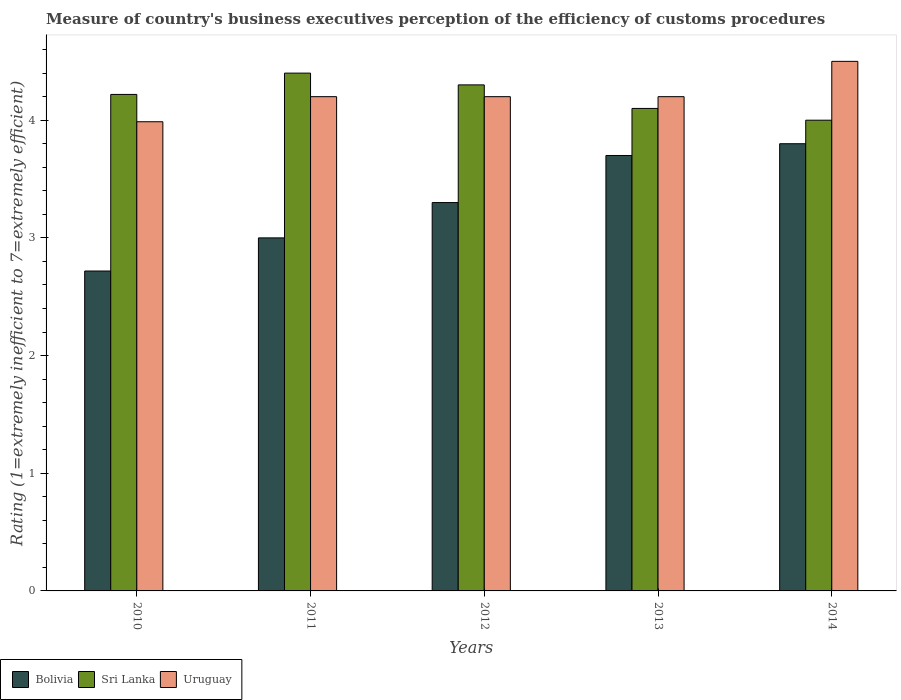How many groups of bars are there?
Make the answer very short. 5. Are the number of bars per tick equal to the number of legend labels?
Provide a short and direct response. Yes. Are the number of bars on each tick of the X-axis equal?
Make the answer very short. Yes. What is the rating of the efficiency of customs procedure in Sri Lanka in 2014?
Ensure brevity in your answer.  4. What is the total rating of the efficiency of customs procedure in Uruguay in the graph?
Your answer should be very brief. 21.09. What is the difference between the rating of the efficiency of customs procedure in Bolivia in 2010 and that in 2014?
Your response must be concise. -1.08. What is the difference between the rating of the efficiency of customs procedure in Sri Lanka in 2010 and the rating of the efficiency of customs procedure in Uruguay in 2013?
Offer a terse response. 0.02. What is the average rating of the efficiency of customs procedure in Uruguay per year?
Your answer should be compact. 4.22. In the year 2012, what is the difference between the rating of the efficiency of customs procedure in Bolivia and rating of the efficiency of customs procedure in Sri Lanka?
Provide a short and direct response. -1. What is the ratio of the rating of the efficiency of customs procedure in Uruguay in 2010 to that in 2012?
Offer a terse response. 0.95. Is the rating of the efficiency of customs procedure in Uruguay in 2011 less than that in 2013?
Ensure brevity in your answer.  No. Is the difference between the rating of the efficiency of customs procedure in Bolivia in 2011 and 2014 greater than the difference between the rating of the efficiency of customs procedure in Sri Lanka in 2011 and 2014?
Provide a short and direct response. No. What is the difference between the highest and the second highest rating of the efficiency of customs procedure in Sri Lanka?
Offer a very short reply. 0.1. What is the difference between the highest and the lowest rating of the efficiency of customs procedure in Sri Lanka?
Ensure brevity in your answer.  0.4. Is the sum of the rating of the efficiency of customs procedure in Uruguay in 2011 and 2013 greater than the maximum rating of the efficiency of customs procedure in Bolivia across all years?
Make the answer very short. Yes. What does the 2nd bar from the left in 2011 represents?
Ensure brevity in your answer.  Sri Lanka. What does the 3rd bar from the right in 2014 represents?
Provide a short and direct response. Bolivia. How many bars are there?
Provide a short and direct response. 15. What is the difference between two consecutive major ticks on the Y-axis?
Your answer should be very brief. 1. Does the graph contain any zero values?
Offer a terse response. No. How are the legend labels stacked?
Your answer should be very brief. Horizontal. What is the title of the graph?
Your answer should be very brief. Measure of country's business executives perception of the efficiency of customs procedures. Does "Austria" appear as one of the legend labels in the graph?
Offer a terse response. No. What is the label or title of the Y-axis?
Offer a terse response. Rating (1=extremely inefficient to 7=extremely efficient). What is the Rating (1=extremely inefficient to 7=extremely efficient) of Bolivia in 2010?
Ensure brevity in your answer.  2.72. What is the Rating (1=extremely inefficient to 7=extremely efficient) in Sri Lanka in 2010?
Your answer should be very brief. 4.22. What is the Rating (1=extremely inefficient to 7=extremely efficient) of Uruguay in 2010?
Keep it short and to the point. 3.99. What is the Rating (1=extremely inefficient to 7=extremely efficient) of Bolivia in 2011?
Give a very brief answer. 3. What is the Rating (1=extremely inefficient to 7=extremely efficient) of Sri Lanka in 2012?
Offer a very short reply. 4.3. What is the Rating (1=extremely inefficient to 7=extremely efficient) of Uruguay in 2012?
Your answer should be very brief. 4.2. What is the Rating (1=extremely inefficient to 7=extremely efficient) in Bolivia in 2014?
Ensure brevity in your answer.  3.8. What is the Rating (1=extremely inefficient to 7=extremely efficient) of Uruguay in 2014?
Your answer should be very brief. 4.5. Across all years, what is the maximum Rating (1=extremely inefficient to 7=extremely efficient) in Bolivia?
Your response must be concise. 3.8. Across all years, what is the minimum Rating (1=extremely inefficient to 7=extremely efficient) in Bolivia?
Offer a terse response. 2.72. Across all years, what is the minimum Rating (1=extremely inefficient to 7=extremely efficient) of Uruguay?
Give a very brief answer. 3.99. What is the total Rating (1=extremely inefficient to 7=extremely efficient) of Bolivia in the graph?
Your answer should be compact. 16.52. What is the total Rating (1=extremely inefficient to 7=extremely efficient) in Sri Lanka in the graph?
Offer a very short reply. 21.02. What is the total Rating (1=extremely inefficient to 7=extremely efficient) in Uruguay in the graph?
Keep it short and to the point. 21.09. What is the difference between the Rating (1=extremely inefficient to 7=extremely efficient) in Bolivia in 2010 and that in 2011?
Provide a short and direct response. -0.28. What is the difference between the Rating (1=extremely inefficient to 7=extremely efficient) of Sri Lanka in 2010 and that in 2011?
Keep it short and to the point. -0.18. What is the difference between the Rating (1=extremely inefficient to 7=extremely efficient) in Uruguay in 2010 and that in 2011?
Keep it short and to the point. -0.21. What is the difference between the Rating (1=extremely inefficient to 7=extremely efficient) of Bolivia in 2010 and that in 2012?
Make the answer very short. -0.58. What is the difference between the Rating (1=extremely inefficient to 7=extremely efficient) in Sri Lanka in 2010 and that in 2012?
Offer a terse response. -0.08. What is the difference between the Rating (1=extremely inefficient to 7=extremely efficient) in Uruguay in 2010 and that in 2012?
Provide a succinct answer. -0.21. What is the difference between the Rating (1=extremely inefficient to 7=extremely efficient) in Bolivia in 2010 and that in 2013?
Provide a short and direct response. -0.98. What is the difference between the Rating (1=extremely inefficient to 7=extremely efficient) in Sri Lanka in 2010 and that in 2013?
Provide a succinct answer. 0.12. What is the difference between the Rating (1=extremely inefficient to 7=extremely efficient) of Uruguay in 2010 and that in 2013?
Your response must be concise. -0.21. What is the difference between the Rating (1=extremely inefficient to 7=extremely efficient) in Bolivia in 2010 and that in 2014?
Your answer should be compact. -1.08. What is the difference between the Rating (1=extremely inefficient to 7=extremely efficient) in Sri Lanka in 2010 and that in 2014?
Keep it short and to the point. 0.22. What is the difference between the Rating (1=extremely inefficient to 7=extremely efficient) of Uruguay in 2010 and that in 2014?
Your response must be concise. -0.51. What is the difference between the Rating (1=extremely inefficient to 7=extremely efficient) of Sri Lanka in 2011 and that in 2012?
Ensure brevity in your answer.  0.1. What is the difference between the Rating (1=extremely inefficient to 7=extremely efficient) of Bolivia in 2011 and that in 2014?
Make the answer very short. -0.8. What is the difference between the Rating (1=extremely inefficient to 7=extremely efficient) in Sri Lanka in 2011 and that in 2014?
Your answer should be very brief. 0.4. What is the difference between the Rating (1=extremely inefficient to 7=extremely efficient) of Uruguay in 2011 and that in 2014?
Your response must be concise. -0.3. What is the difference between the Rating (1=extremely inefficient to 7=extremely efficient) in Uruguay in 2012 and that in 2013?
Your response must be concise. 0. What is the difference between the Rating (1=extremely inefficient to 7=extremely efficient) of Bolivia in 2012 and that in 2014?
Give a very brief answer. -0.5. What is the difference between the Rating (1=extremely inefficient to 7=extremely efficient) in Uruguay in 2013 and that in 2014?
Give a very brief answer. -0.3. What is the difference between the Rating (1=extremely inefficient to 7=extremely efficient) in Bolivia in 2010 and the Rating (1=extremely inefficient to 7=extremely efficient) in Sri Lanka in 2011?
Your response must be concise. -1.68. What is the difference between the Rating (1=extremely inefficient to 7=extremely efficient) in Bolivia in 2010 and the Rating (1=extremely inefficient to 7=extremely efficient) in Uruguay in 2011?
Provide a short and direct response. -1.48. What is the difference between the Rating (1=extremely inefficient to 7=extremely efficient) of Sri Lanka in 2010 and the Rating (1=extremely inefficient to 7=extremely efficient) of Uruguay in 2011?
Provide a short and direct response. 0.02. What is the difference between the Rating (1=extremely inefficient to 7=extremely efficient) of Bolivia in 2010 and the Rating (1=extremely inefficient to 7=extremely efficient) of Sri Lanka in 2012?
Ensure brevity in your answer.  -1.58. What is the difference between the Rating (1=extremely inefficient to 7=extremely efficient) of Bolivia in 2010 and the Rating (1=extremely inefficient to 7=extremely efficient) of Uruguay in 2012?
Your response must be concise. -1.48. What is the difference between the Rating (1=extremely inefficient to 7=extremely efficient) in Sri Lanka in 2010 and the Rating (1=extremely inefficient to 7=extremely efficient) in Uruguay in 2012?
Your answer should be very brief. 0.02. What is the difference between the Rating (1=extremely inefficient to 7=extremely efficient) of Bolivia in 2010 and the Rating (1=extremely inefficient to 7=extremely efficient) of Sri Lanka in 2013?
Give a very brief answer. -1.38. What is the difference between the Rating (1=extremely inefficient to 7=extremely efficient) of Bolivia in 2010 and the Rating (1=extremely inefficient to 7=extremely efficient) of Uruguay in 2013?
Make the answer very short. -1.48. What is the difference between the Rating (1=extremely inefficient to 7=extremely efficient) of Sri Lanka in 2010 and the Rating (1=extremely inefficient to 7=extremely efficient) of Uruguay in 2013?
Give a very brief answer. 0.02. What is the difference between the Rating (1=extremely inefficient to 7=extremely efficient) in Bolivia in 2010 and the Rating (1=extremely inefficient to 7=extremely efficient) in Sri Lanka in 2014?
Your answer should be compact. -1.28. What is the difference between the Rating (1=extremely inefficient to 7=extremely efficient) of Bolivia in 2010 and the Rating (1=extremely inefficient to 7=extremely efficient) of Uruguay in 2014?
Provide a succinct answer. -1.78. What is the difference between the Rating (1=extremely inefficient to 7=extremely efficient) of Sri Lanka in 2010 and the Rating (1=extremely inefficient to 7=extremely efficient) of Uruguay in 2014?
Offer a terse response. -0.28. What is the difference between the Rating (1=extremely inefficient to 7=extremely efficient) of Bolivia in 2011 and the Rating (1=extremely inefficient to 7=extremely efficient) of Sri Lanka in 2012?
Provide a succinct answer. -1.3. What is the difference between the Rating (1=extremely inefficient to 7=extremely efficient) in Bolivia in 2011 and the Rating (1=extremely inefficient to 7=extremely efficient) in Uruguay in 2013?
Your answer should be compact. -1.2. What is the difference between the Rating (1=extremely inefficient to 7=extremely efficient) in Sri Lanka in 2011 and the Rating (1=extremely inefficient to 7=extremely efficient) in Uruguay in 2013?
Your response must be concise. 0.2. What is the difference between the Rating (1=extremely inefficient to 7=extremely efficient) of Bolivia in 2011 and the Rating (1=extremely inefficient to 7=extremely efficient) of Sri Lanka in 2014?
Provide a short and direct response. -1. What is the difference between the Rating (1=extremely inefficient to 7=extremely efficient) in Bolivia in 2012 and the Rating (1=extremely inefficient to 7=extremely efficient) in Uruguay in 2013?
Provide a succinct answer. -0.9. What is the difference between the Rating (1=extremely inefficient to 7=extremely efficient) in Bolivia in 2012 and the Rating (1=extremely inefficient to 7=extremely efficient) in Sri Lanka in 2014?
Your answer should be very brief. -0.7. What is the difference between the Rating (1=extremely inefficient to 7=extremely efficient) of Sri Lanka in 2013 and the Rating (1=extremely inefficient to 7=extremely efficient) of Uruguay in 2014?
Your answer should be very brief. -0.4. What is the average Rating (1=extremely inefficient to 7=extremely efficient) in Bolivia per year?
Your answer should be compact. 3.3. What is the average Rating (1=extremely inefficient to 7=extremely efficient) in Sri Lanka per year?
Your response must be concise. 4.2. What is the average Rating (1=extremely inefficient to 7=extremely efficient) of Uruguay per year?
Your answer should be very brief. 4.22. In the year 2010, what is the difference between the Rating (1=extremely inefficient to 7=extremely efficient) of Bolivia and Rating (1=extremely inefficient to 7=extremely efficient) of Sri Lanka?
Your answer should be compact. -1.5. In the year 2010, what is the difference between the Rating (1=extremely inefficient to 7=extremely efficient) in Bolivia and Rating (1=extremely inefficient to 7=extremely efficient) in Uruguay?
Make the answer very short. -1.27. In the year 2010, what is the difference between the Rating (1=extremely inefficient to 7=extremely efficient) in Sri Lanka and Rating (1=extremely inefficient to 7=extremely efficient) in Uruguay?
Provide a short and direct response. 0.23. In the year 2011, what is the difference between the Rating (1=extremely inefficient to 7=extremely efficient) in Bolivia and Rating (1=extremely inefficient to 7=extremely efficient) in Sri Lanka?
Keep it short and to the point. -1.4. In the year 2011, what is the difference between the Rating (1=extremely inefficient to 7=extremely efficient) of Sri Lanka and Rating (1=extremely inefficient to 7=extremely efficient) of Uruguay?
Ensure brevity in your answer.  0.2. In the year 2012, what is the difference between the Rating (1=extremely inefficient to 7=extremely efficient) in Bolivia and Rating (1=extremely inefficient to 7=extremely efficient) in Uruguay?
Offer a very short reply. -0.9. In the year 2013, what is the difference between the Rating (1=extremely inefficient to 7=extremely efficient) in Bolivia and Rating (1=extremely inefficient to 7=extremely efficient) in Uruguay?
Give a very brief answer. -0.5. What is the ratio of the Rating (1=extremely inefficient to 7=extremely efficient) of Bolivia in 2010 to that in 2011?
Keep it short and to the point. 0.91. What is the ratio of the Rating (1=extremely inefficient to 7=extremely efficient) of Sri Lanka in 2010 to that in 2011?
Provide a short and direct response. 0.96. What is the ratio of the Rating (1=extremely inefficient to 7=extremely efficient) of Uruguay in 2010 to that in 2011?
Provide a short and direct response. 0.95. What is the ratio of the Rating (1=extremely inefficient to 7=extremely efficient) in Bolivia in 2010 to that in 2012?
Offer a terse response. 0.82. What is the ratio of the Rating (1=extremely inefficient to 7=extremely efficient) in Sri Lanka in 2010 to that in 2012?
Your answer should be very brief. 0.98. What is the ratio of the Rating (1=extremely inefficient to 7=extremely efficient) of Uruguay in 2010 to that in 2012?
Keep it short and to the point. 0.95. What is the ratio of the Rating (1=extremely inefficient to 7=extremely efficient) of Bolivia in 2010 to that in 2013?
Your response must be concise. 0.73. What is the ratio of the Rating (1=extremely inefficient to 7=extremely efficient) of Uruguay in 2010 to that in 2013?
Offer a very short reply. 0.95. What is the ratio of the Rating (1=extremely inefficient to 7=extremely efficient) in Bolivia in 2010 to that in 2014?
Make the answer very short. 0.72. What is the ratio of the Rating (1=extremely inefficient to 7=extremely efficient) of Sri Lanka in 2010 to that in 2014?
Your answer should be compact. 1.05. What is the ratio of the Rating (1=extremely inefficient to 7=extremely efficient) of Uruguay in 2010 to that in 2014?
Provide a short and direct response. 0.89. What is the ratio of the Rating (1=extremely inefficient to 7=extremely efficient) in Bolivia in 2011 to that in 2012?
Provide a short and direct response. 0.91. What is the ratio of the Rating (1=extremely inefficient to 7=extremely efficient) of Sri Lanka in 2011 to that in 2012?
Offer a very short reply. 1.02. What is the ratio of the Rating (1=extremely inefficient to 7=extremely efficient) of Bolivia in 2011 to that in 2013?
Provide a succinct answer. 0.81. What is the ratio of the Rating (1=extremely inefficient to 7=extremely efficient) of Sri Lanka in 2011 to that in 2013?
Provide a short and direct response. 1.07. What is the ratio of the Rating (1=extremely inefficient to 7=extremely efficient) of Bolivia in 2011 to that in 2014?
Make the answer very short. 0.79. What is the ratio of the Rating (1=extremely inefficient to 7=extremely efficient) in Bolivia in 2012 to that in 2013?
Your answer should be very brief. 0.89. What is the ratio of the Rating (1=extremely inefficient to 7=extremely efficient) in Sri Lanka in 2012 to that in 2013?
Provide a succinct answer. 1.05. What is the ratio of the Rating (1=extremely inefficient to 7=extremely efficient) in Uruguay in 2012 to that in 2013?
Offer a very short reply. 1. What is the ratio of the Rating (1=extremely inefficient to 7=extremely efficient) of Bolivia in 2012 to that in 2014?
Offer a very short reply. 0.87. What is the ratio of the Rating (1=extremely inefficient to 7=extremely efficient) of Sri Lanka in 2012 to that in 2014?
Provide a short and direct response. 1.07. What is the ratio of the Rating (1=extremely inefficient to 7=extremely efficient) of Bolivia in 2013 to that in 2014?
Provide a short and direct response. 0.97. What is the ratio of the Rating (1=extremely inefficient to 7=extremely efficient) in Sri Lanka in 2013 to that in 2014?
Your answer should be compact. 1.02. What is the difference between the highest and the second highest Rating (1=extremely inefficient to 7=extremely efficient) of Sri Lanka?
Your response must be concise. 0.1. What is the difference between the highest and the second highest Rating (1=extremely inefficient to 7=extremely efficient) in Uruguay?
Keep it short and to the point. 0.3. What is the difference between the highest and the lowest Rating (1=extremely inefficient to 7=extremely efficient) in Bolivia?
Give a very brief answer. 1.08. What is the difference between the highest and the lowest Rating (1=extremely inefficient to 7=extremely efficient) in Uruguay?
Offer a terse response. 0.51. 